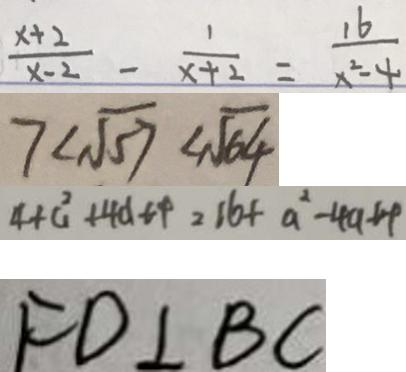Convert formula to latex. <formula><loc_0><loc_0><loc_500><loc_500>\frac { x + 2 } { x - 2 } - \frac { 1 } { x + 2 } = \frac { 1 6 } { x ^ { 2 } - 4 } 
 7 < \sqrt { 5 7 } < \sqrt { 6 4 } 
 4 + a ^ { 2 } + 4 d t + = 1 6 + a ^ { 2 } - 4 a + 4 
 F D \bot B C</formula> 